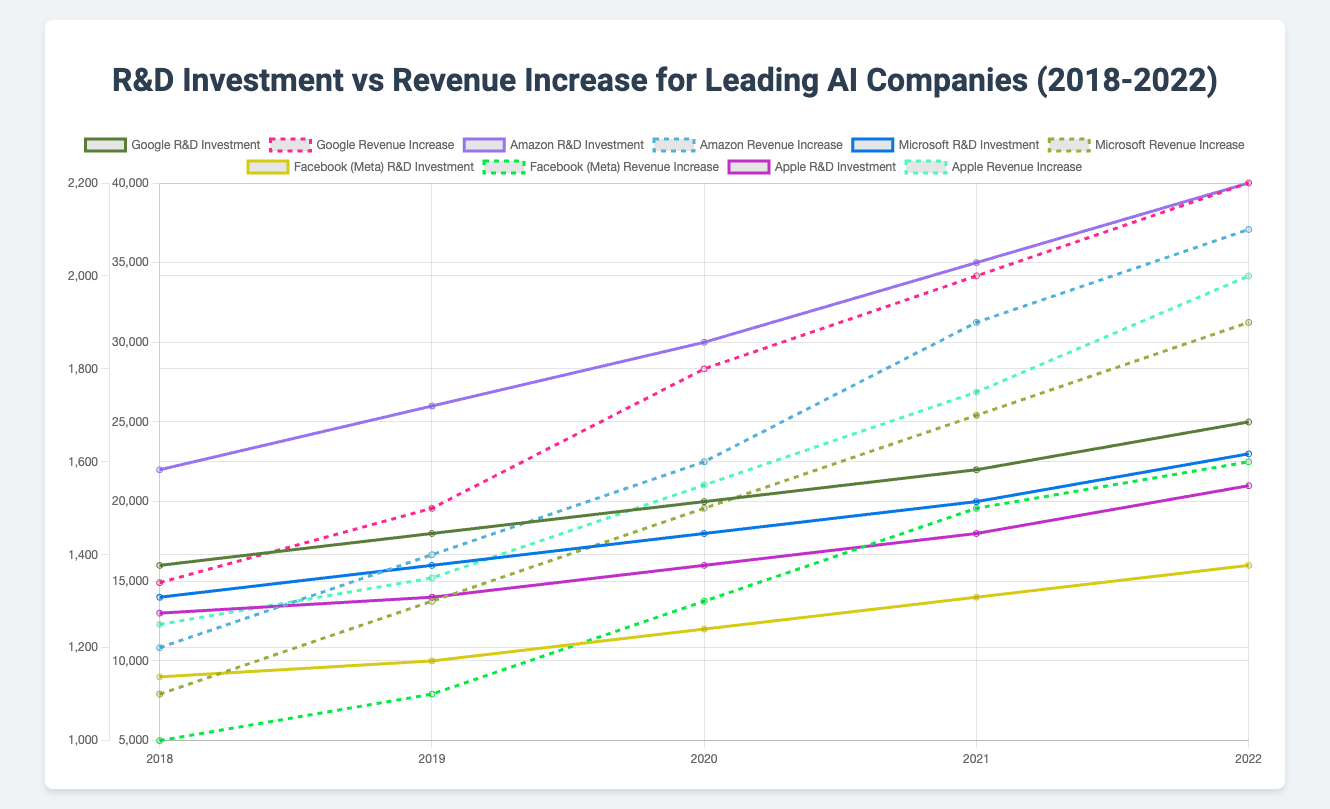What is the total R&D investment by Google over the years 2018 to 2022? Google’s R&D investments from 2018 to 2022 are listed as [16000, 18000, 20000, 22000, 25000]. Summing these values gives 16000 + 18000 + 20000 + 22000 + 25000 = 101000 (in millions), which is equivalent to 101 billion USD.
Answer: 101 billion USD Which company had the highest revenue increase in 2022? In 2022, the revenue increases for the companies are Google (2200), Amazon (2100), Microsoft (1900), Facebook (Meta) (1600), and Apple (2000). The highest among these values is 2200 million USD for Google.
Answer: Google What is the difference in R&D investments between Amazon and Microsoft in 2022? In 2022, Amazon’s R&D investment is 40000 million USD, and Microsoft’s is 23000 million USD. The difference is 40000 - 23000 = 17000 million USD.
Answer: 17000 million USD How does Facebook's (Meta's) revenue increase in 2019 compare to Google's revenue increase in the same year? In 2019, Facebook (Meta) had a revenue increase of 1100 million USD, while Google had a revenue increase of 1500 million USD. Comparing these, 1100 million USD (Facebook) is less than 1500 million USD (Google).
Answer: Less What is the average R&D investment by Apple from 2018 to 2022? Apple’s R&D investments from 2018 to 2022 are [13000, 14000, 16000, 18000, 21000]. The sum of these values is 13000 + 14000 + 16000 + 18000 + 21000 = 82000 million USD. The average is 82000 / 5 = 16400 million USD.
Answer: 16400 million USD Which company shows the steadiest increase in R&D investment over the years? By examining the trends, each company shows an increase, but Amazon’s R&D investments [22000, 26000, 30000, 35000, 40000] increase steadily by about 4000-5000 million USD every year, indicating a steady increase.
Answer: Amazon What is the combined revenue increase of all companies in 2020? In 2020, the revenue increases for the companies are Google (1800), Amazon (1600), Microsoft (1500), Facebook (Meta) (1300), Apple (1550). Summing these gives 1800 + 1600 + 1500 + 1300 + 1550 = 7750 million USD.
Answer: 7750 million USD By how much did Microsoft's R&D investment in 2022 increase compared to its investment in 2018? In 2022, Microsoft's R&D investment is 23000 million USD, and in 2018, it was 14000 million USD. The increase over these years is 23000 - 14000 = 9000 million USD.
Answer: 9000 million USD 